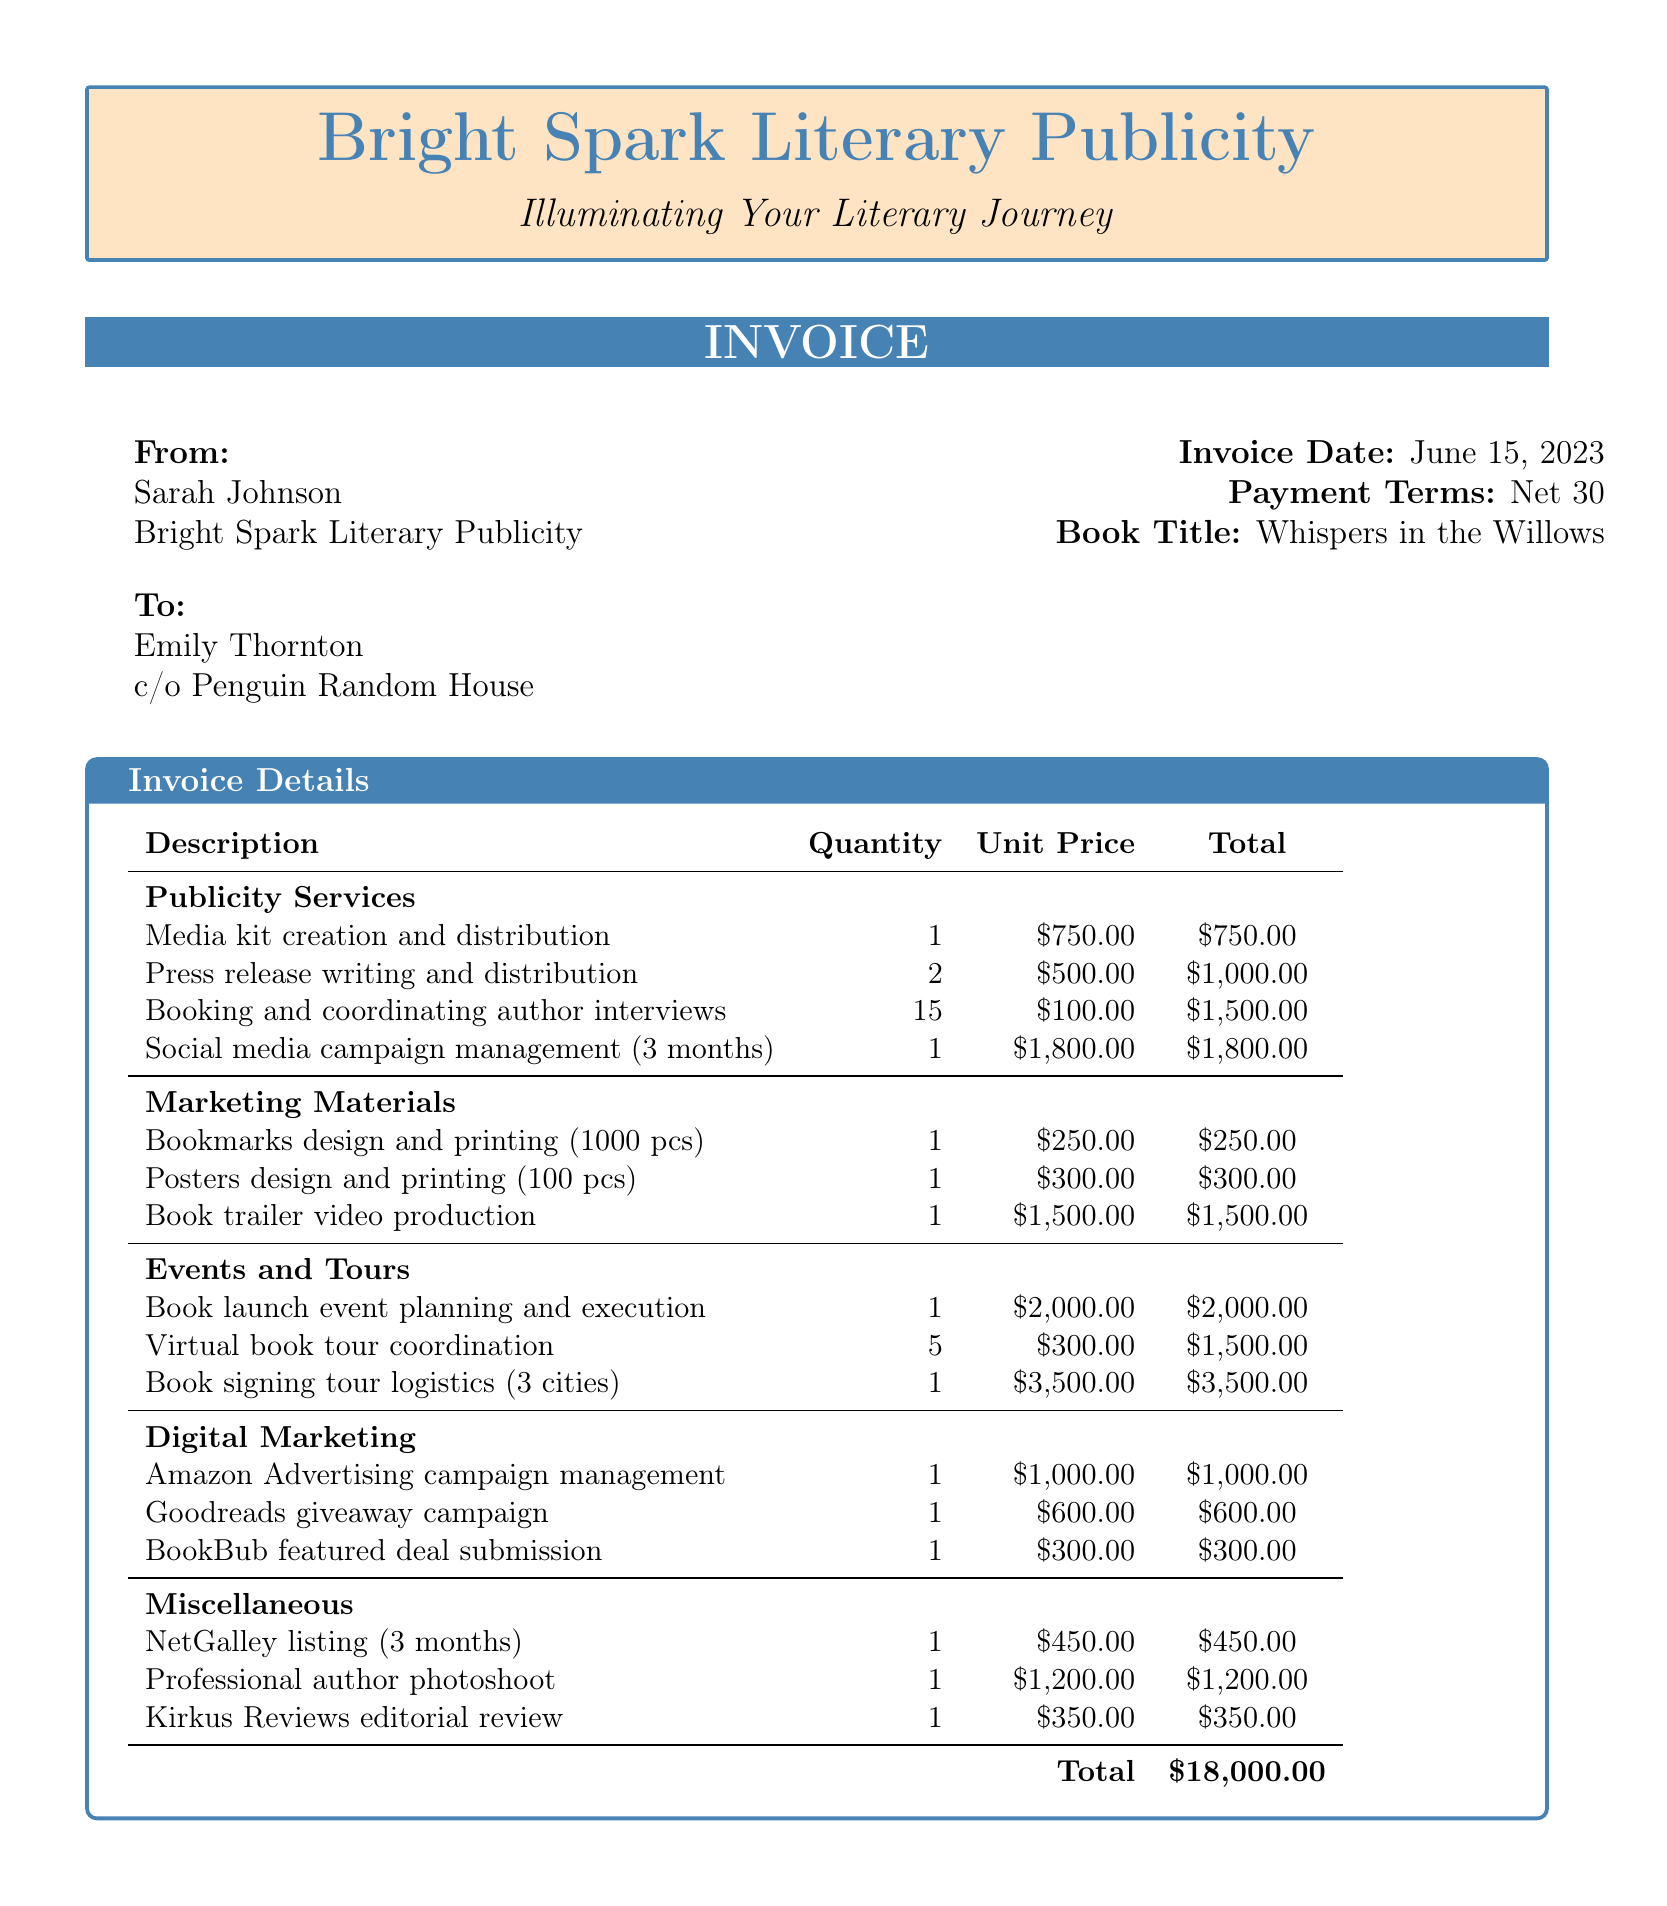What is the total amount of the invoice? The total amount of the invoice is provided in the document.
Answer: $18,000.00 Who is the author of the book? The author’s name is listed prominently in the document.
Answer: Emily Thornton What is the due date for payment? The payment terms state that it is due within a specific time frame.
Answer: Net 30 How many author interviews were booked? The number of booked author interviews is stated in the document.
Answer: 15 What is the cost of the book trailer video production? The unit price for the book trailer video production is listed.
Answer: $1,500.00 What company does the publicist work for? The publicist's company is specified in the document header.
Answer: Bright Spark Literary Publicity What event is mentioned for planning and execution? An event type is detailed in the events and tours section.
Answer: Book launch event What is the quantity of virtual book tour coordination? The quantity for virtual book tour coordination is provided in the document.
Answer: 5 What type of review is listed under Miscellaneous? The type of review is specifically mentioned in the document.
Answer: Kirkus Reviews editorial review 